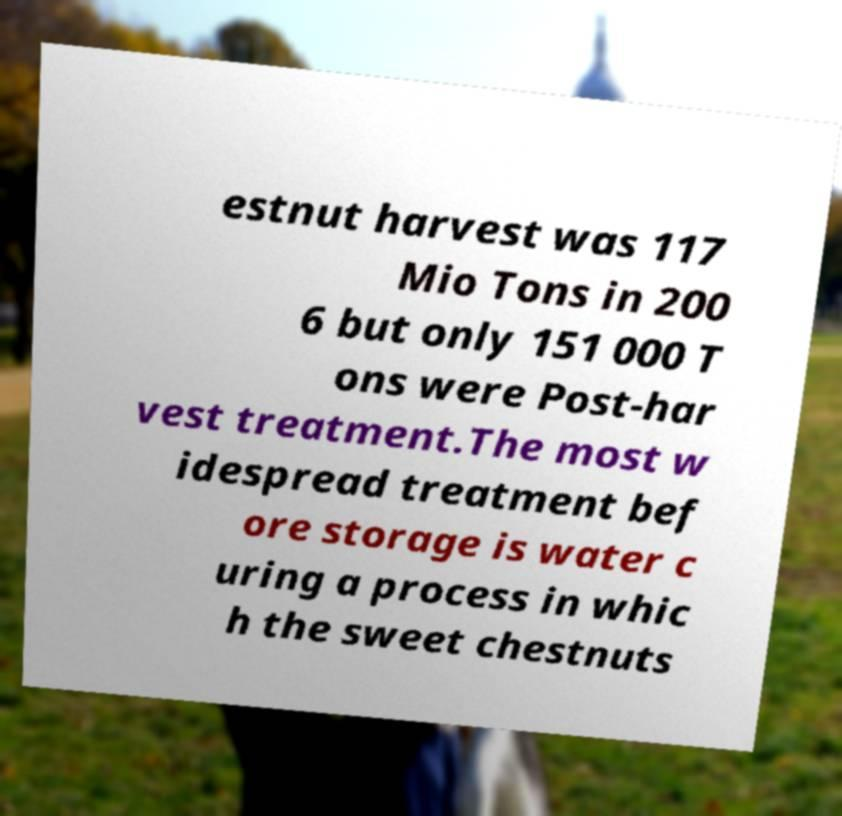There's text embedded in this image that I need extracted. Can you transcribe it verbatim? estnut harvest was 117 Mio Tons in 200 6 but only 151 000 T ons were Post-har vest treatment.The most w idespread treatment bef ore storage is water c uring a process in whic h the sweet chestnuts 